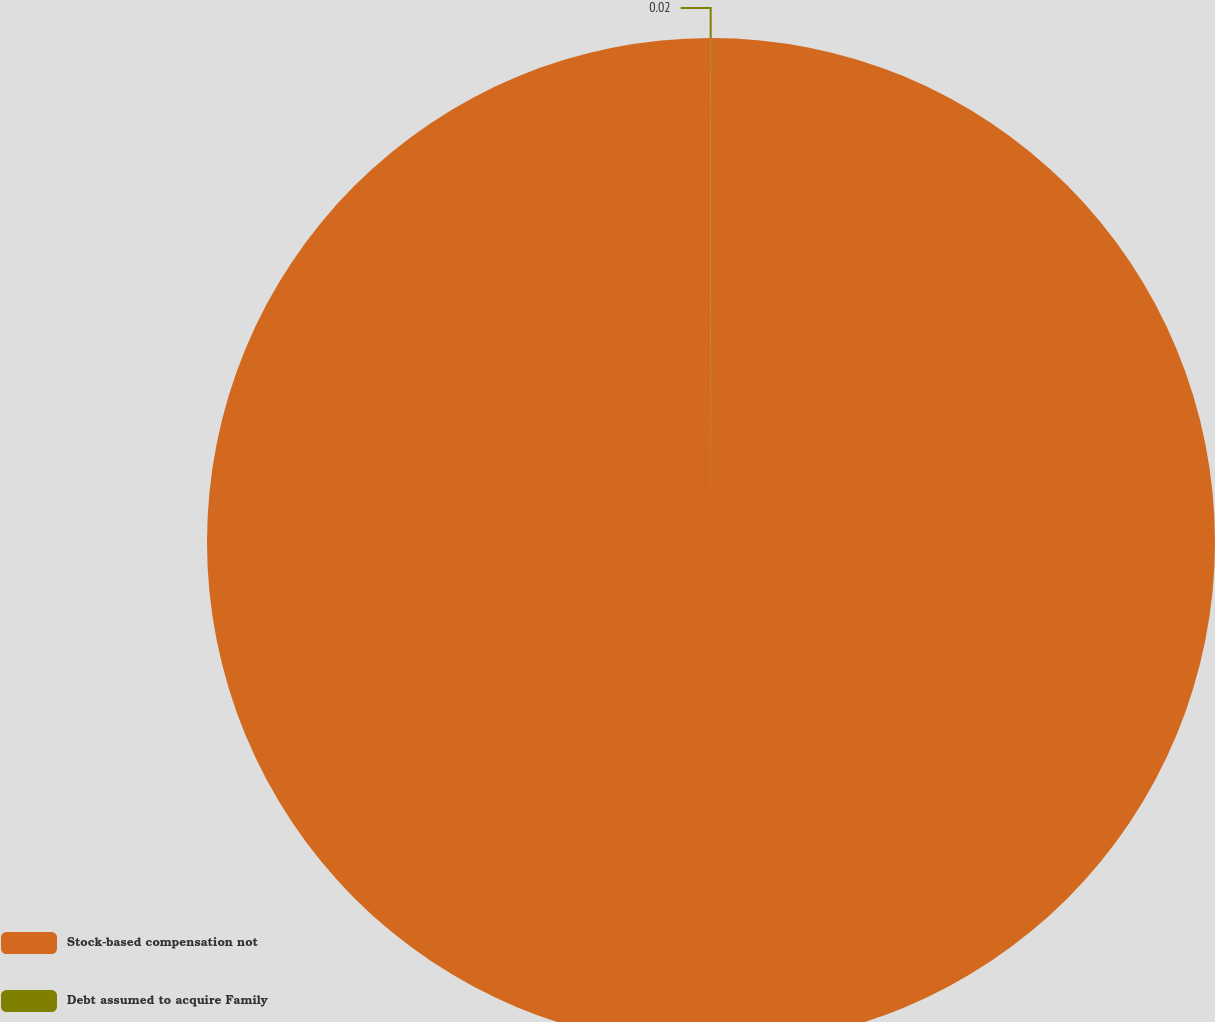<chart> <loc_0><loc_0><loc_500><loc_500><pie_chart><fcel>Stock-based compensation not<fcel>Debt assumed to acquire Family<nl><fcel>99.98%<fcel>0.02%<nl></chart> 